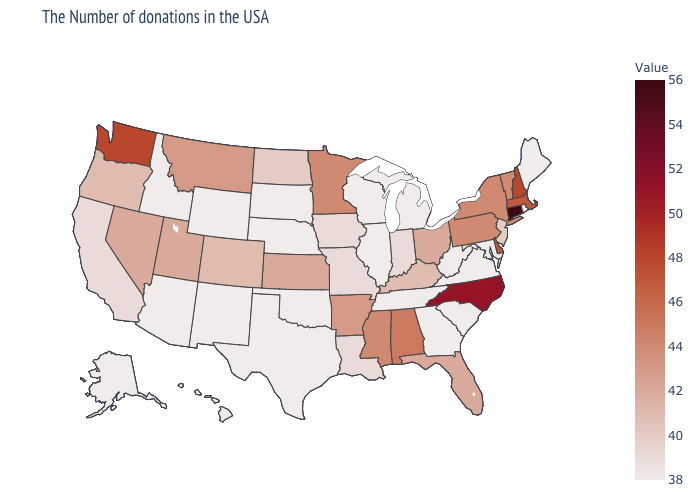Which states have the highest value in the USA?
Be succinct. Connecticut. Among the states that border Nevada , does Idaho have the lowest value?
Answer briefly. Yes. Does Kansas have the lowest value in the MidWest?
Quick response, please. No. Does Georgia have the lowest value in the USA?
Write a very short answer. Yes. 